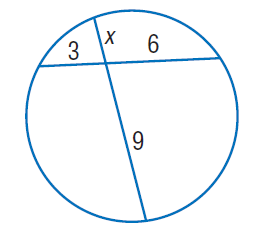Answer the mathemtical geometry problem and directly provide the correct option letter.
Question: Find x. Round to the nearest tenth if necessary.
Choices: A: 2 B: 3 C: 6 D: 9 A 